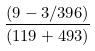<formula> <loc_0><loc_0><loc_500><loc_500>\frac { ( 9 - 3 / 3 9 6 ) } { ( 1 1 9 + 4 9 3 ) }</formula> 